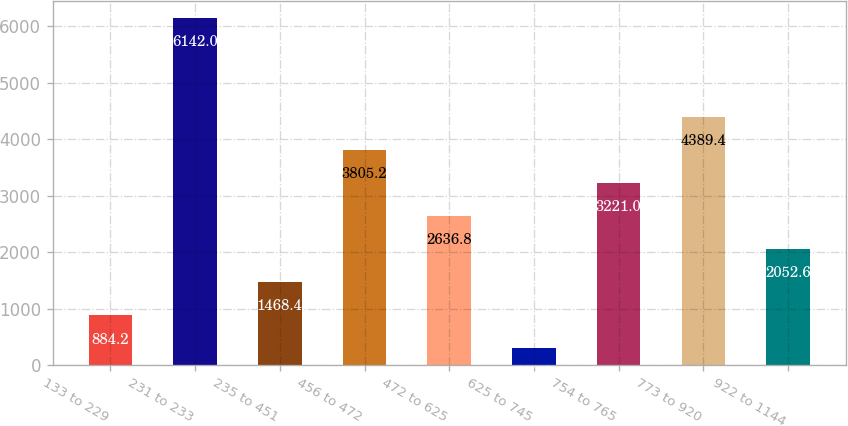<chart> <loc_0><loc_0><loc_500><loc_500><bar_chart><fcel>133 to 229<fcel>231 to 233<fcel>235 to 451<fcel>456 to 472<fcel>472 to 625<fcel>625 to 745<fcel>754 to 765<fcel>773 to 920<fcel>922 to 1144<nl><fcel>884.2<fcel>6142<fcel>1468.4<fcel>3805.2<fcel>2636.8<fcel>300<fcel>3221<fcel>4389.4<fcel>2052.6<nl></chart> 